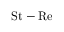<formula> <loc_0><loc_0><loc_500><loc_500>S t - R e</formula> 